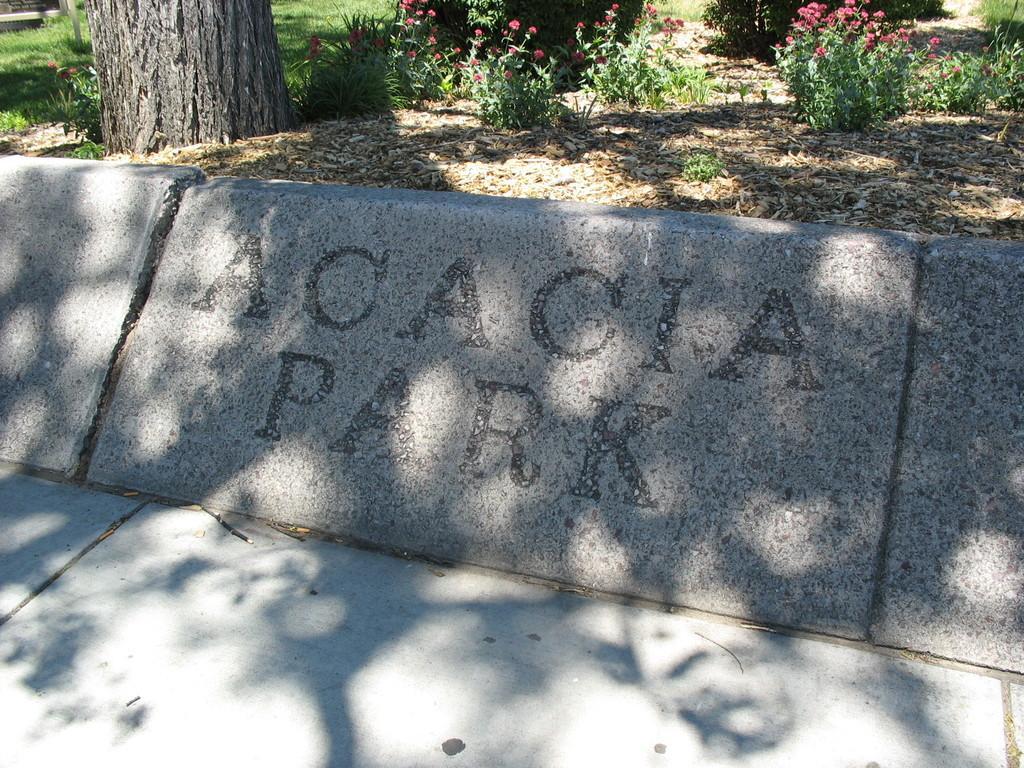Can you describe this image briefly? In the foreground of this image, at the bottom, there is stone surface and also there is some text on the stone in the middle. At the top, there are flowers, plants, grass and a tree trunk. 